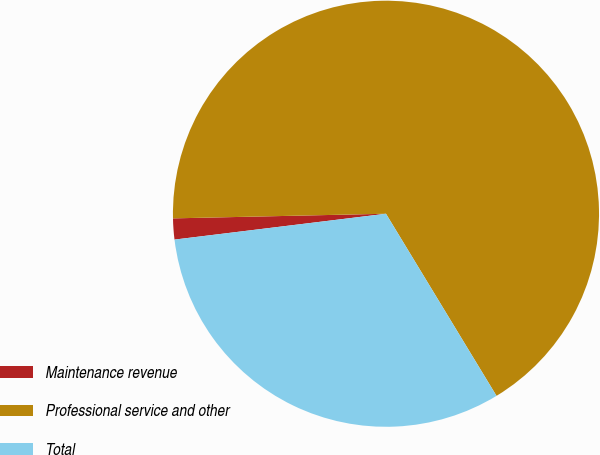<chart> <loc_0><loc_0><loc_500><loc_500><pie_chart><fcel>Maintenance revenue<fcel>Professional service and other<fcel>Total<nl><fcel>1.59%<fcel>66.67%<fcel>31.75%<nl></chart> 